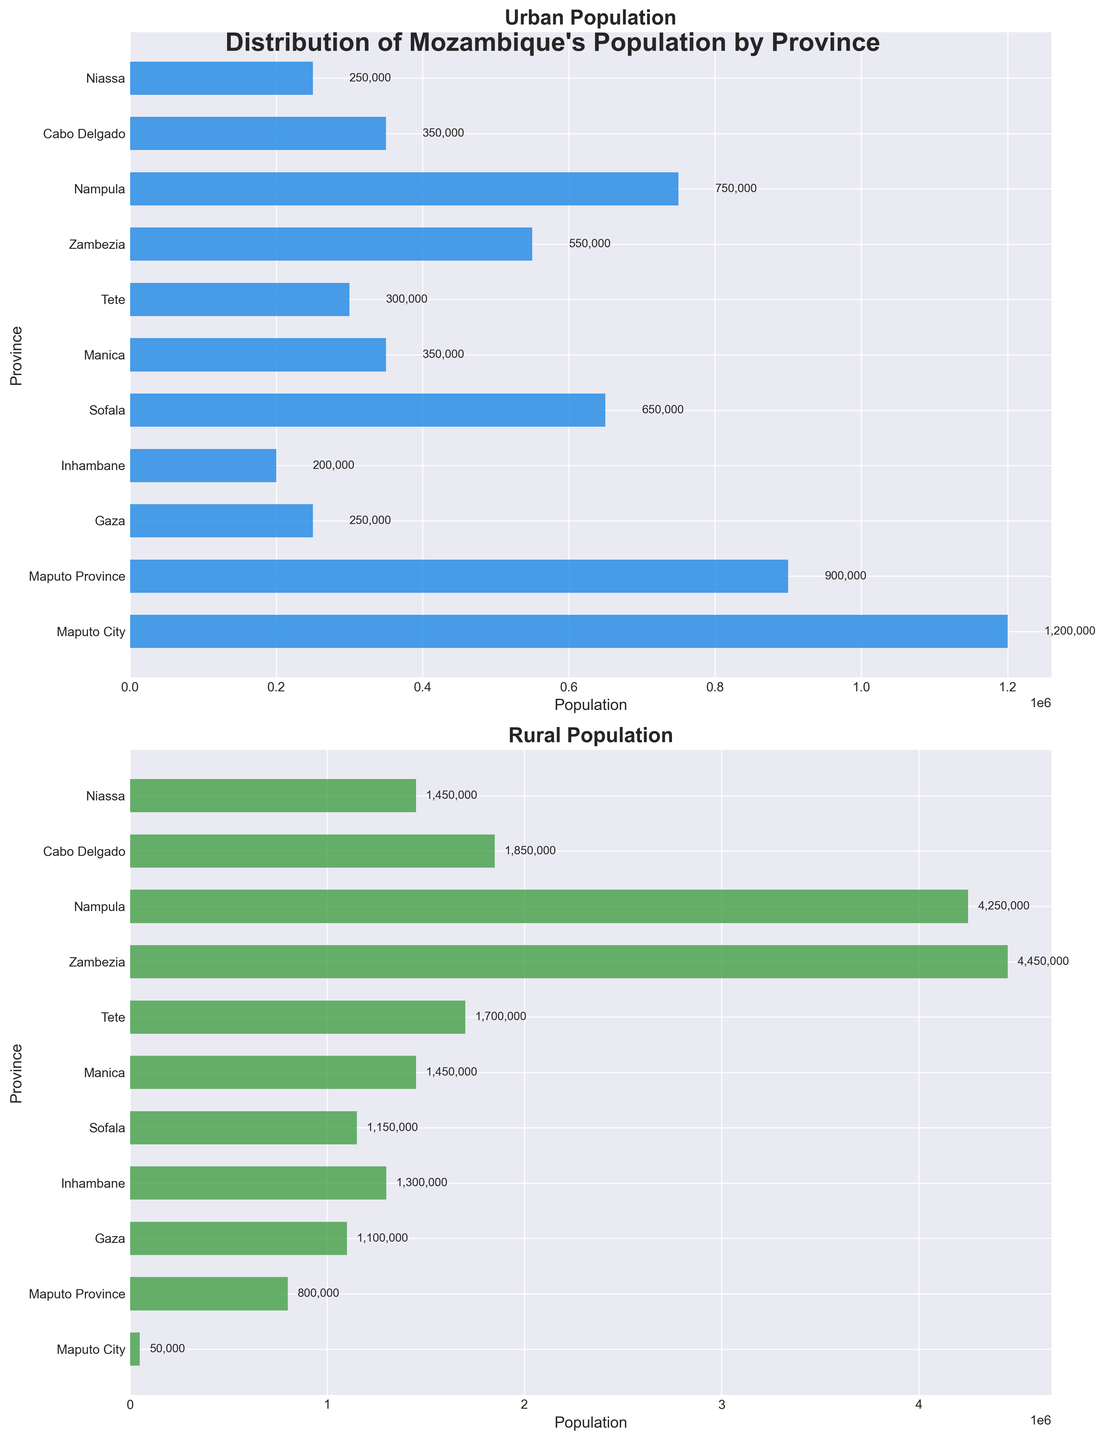Which province has the highest urban population? The bar corresponding to Maputo City extends the farthest to the right on the urban population plot.
Answer: Maputo City Which has a greater difference between rural and urban populations, Nampula or Zambezia? For Nampula, the rural population is 4,250,000 and the urban population is 750,000, a difference of 3,500,000. For Zambezia, the rural population is 4,450,000 and the urban population is 550,000, a difference of 3,900,000.
Answer: Zambezia Which province has a higher proportion of its population in rural areas, Cabo Delgado or Inhambane? In Cabo Delgado, the rural population (1,850,000) is much larger than the urban population (350,000). In Inhambane, the rural population (1,300,000) is larger than the urban population (200,000). The ratio is higher in Cabo Delgado since 1,850,000 is proportionally greater compared to 350,000 than for Inhambane.
Answer: Cabo Delgado What is the total urban population for all provinces combined? Sum the urban populations: 1,200,000 (Maputo City) + 900,000 (Maputo Province) + 250,000 (Gaza) + 200,000 (Inhambane) + 650,000 (Sofala) + 350,000 (Manica) + 300,000 (Tete) + 550,000 (Zambezia) + 750,000 (Nampula) + 350,000 (Cabo Delgado) + 250,000 (Niassa) = 5,750,000.
Answer: 5,750,000 Which province has the smallest rural population? The bar corresponding to Maputo City extends the least to the right on the rural population plot.
Answer: Maputo City Is the urban population of any province greater than the combined urban population of Gaza and Inhambane? The urban populations are 250,000 (Gaza) + 200,000 (Inhambane) = 450,000. Maputo City (1,200,000), Maputo Province (900,000), Nampula (750,000), and Sofala (650,000) each have an urban population greater than 450,000.
Answer: Yes What is the total rural population in the central provinces (Manica, Sofala, Tete)? Sum the rural populations of Manica, Sofala, and Tete: 1,450,000 (Manica) + 1,150,000 (Sofala) + 1,700,000 (Tete) = 4,300,000.
Answer: 4,300,000 Which province shows the largest gap between urban and rural populations visually? Zambezia shows the largest visual gap since the rural bar is significantly longer than the urban bar.
Answer: Zambezia Which two provinces have urban populations within 100,000 of each other? Cabo Delgado and Manica each have urban populations of 350,000.
Answer: Cabo Delgado and Manica 